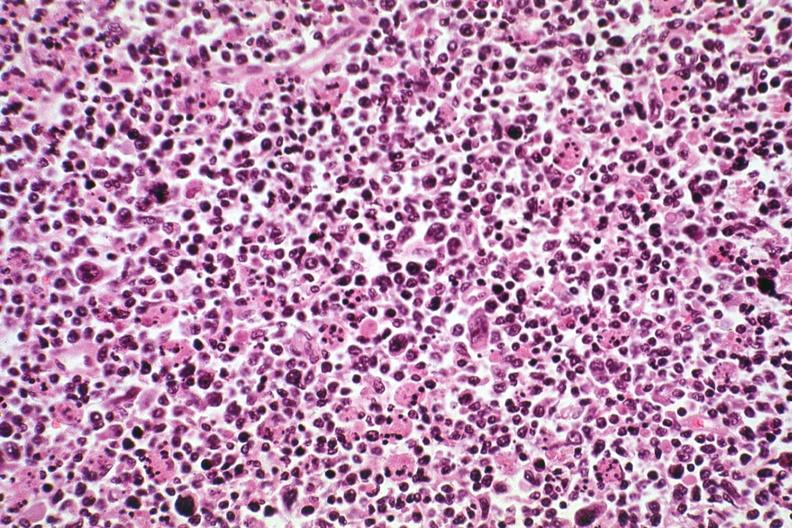what is present?
Answer the question using a single word or phrase. Lymphoma 